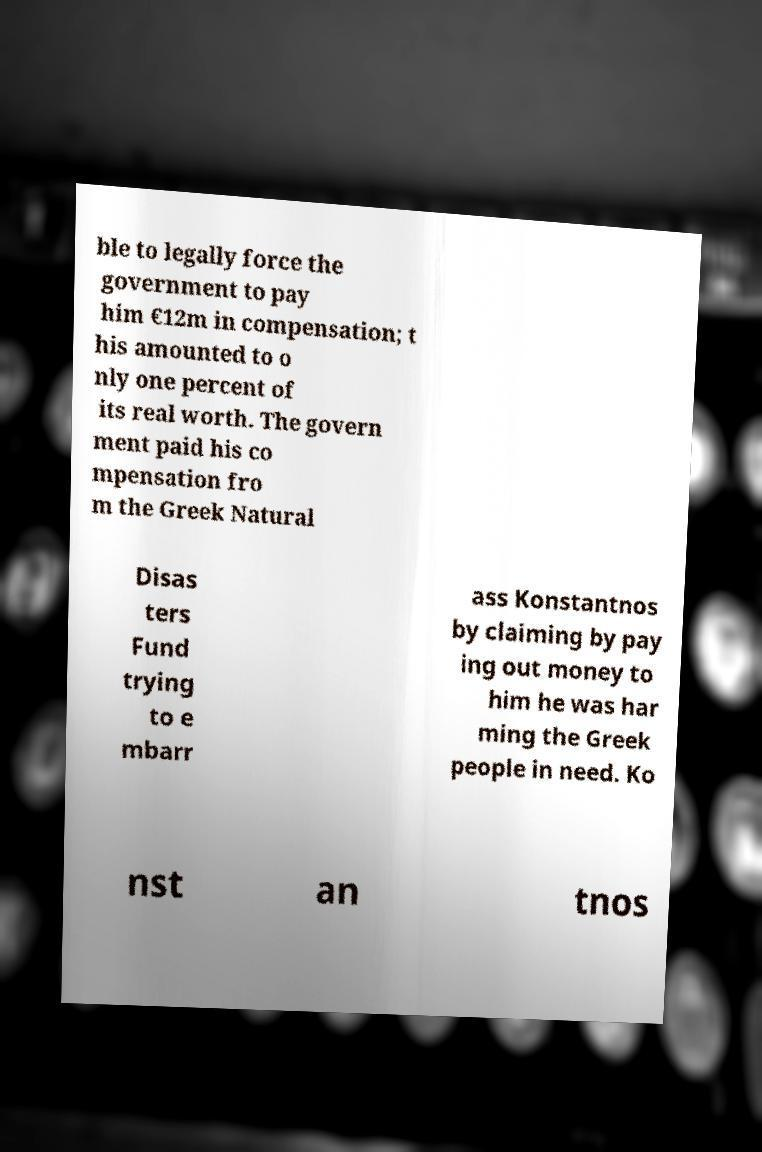Could you assist in decoding the text presented in this image and type it out clearly? ble to legally force the government to pay him €12m in compensation; t his amounted to o nly one percent of its real worth. The govern ment paid his co mpensation fro m the Greek Natural Disas ters Fund trying to e mbarr ass Konstantnos by claiming by pay ing out money to him he was har ming the Greek people in need. Ko nst an tnos 